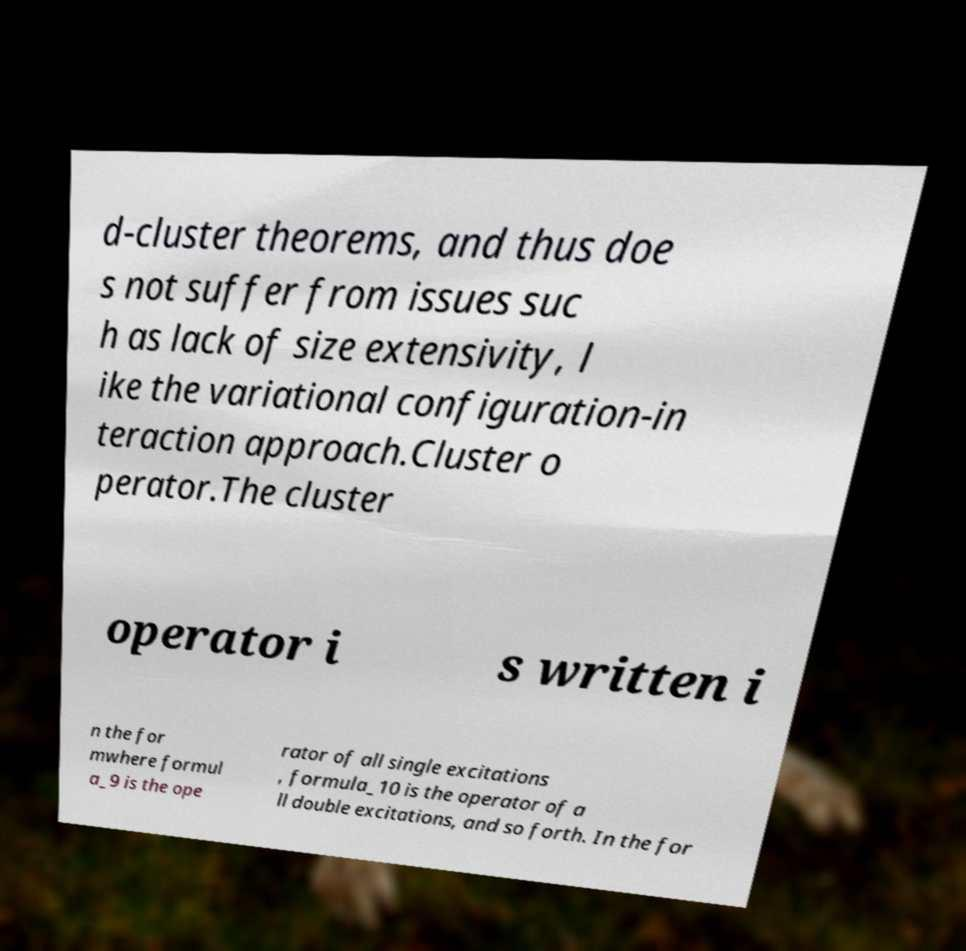For documentation purposes, I need the text within this image transcribed. Could you provide that? d-cluster theorems, and thus doe s not suffer from issues suc h as lack of size extensivity, l ike the variational configuration-in teraction approach.Cluster o perator.The cluster operator i s written i n the for mwhere formul a_9 is the ope rator of all single excitations , formula_10 is the operator of a ll double excitations, and so forth. In the for 